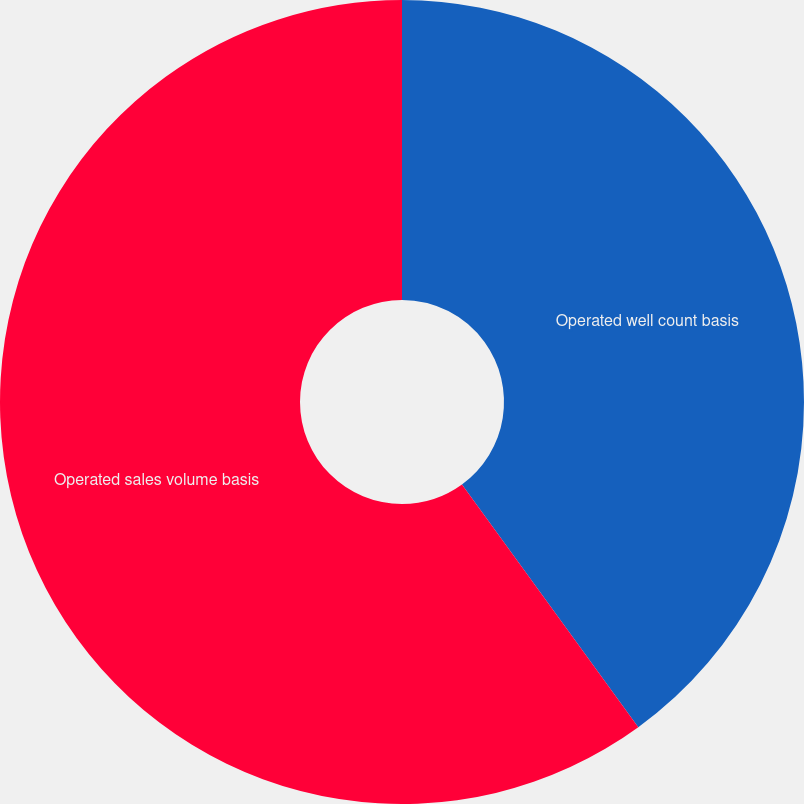Convert chart. <chart><loc_0><loc_0><loc_500><loc_500><pie_chart><fcel>Operated well count basis<fcel>Operated sales volume basis<nl><fcel>40.0%<fcel>60.0%<nl></chart> 